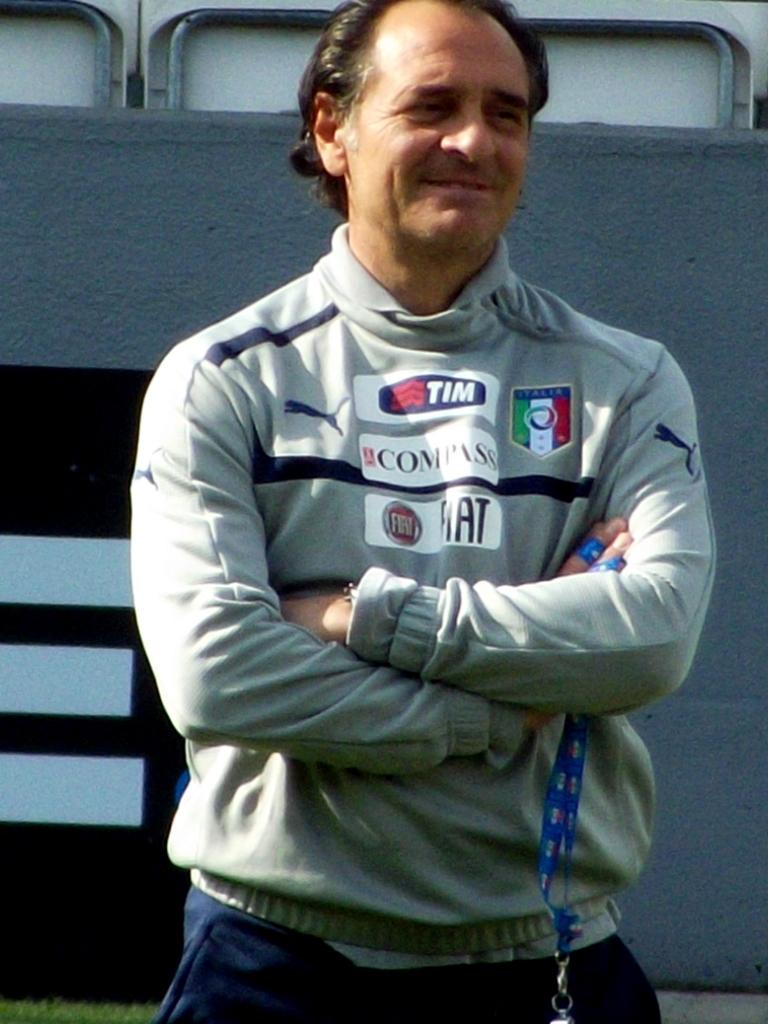<image>
Relay a brief, clear account of the picture shown. A man has his arms crossed, and he is wearing a shirt with Fiat and Compass on it. 